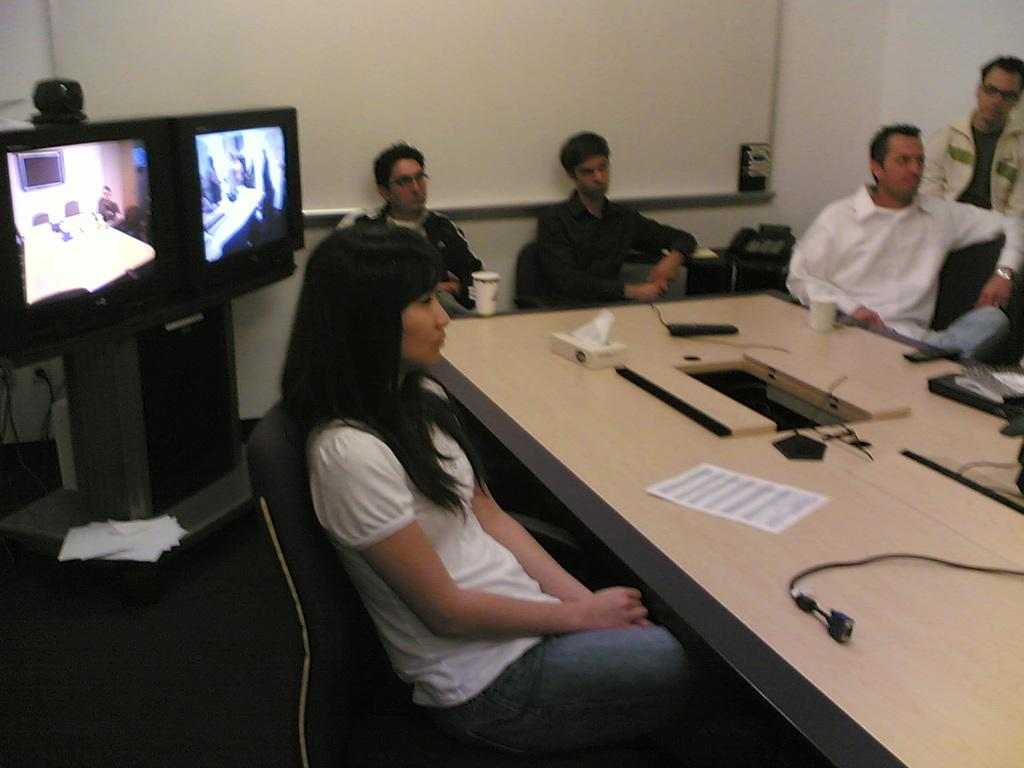What are the people in the image doing? The people in the image are sitting on chairs around a table. What can be seen on the left side of the image? There is a television on the left side of the image. What is visible in the background of the image? There is a wall in the background of the image. What type of pin can be seen holding the wall together in the image? There is no pin visible in the image, and the wall does not appear to be held together by any pins. 